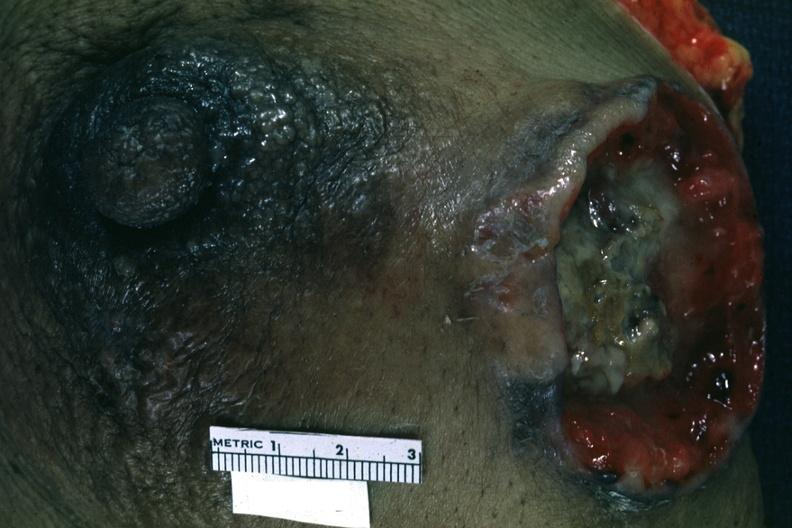what is close-up excised?
Answer the question using a single word or phrase. Up excised breast with large ulcerating carcinoma 